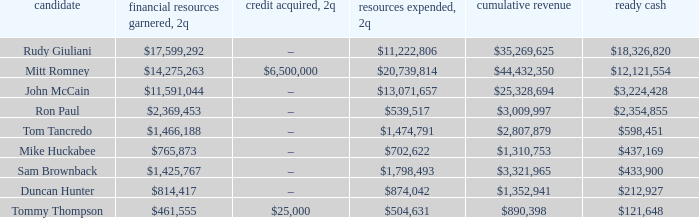Give me the full table as a dictionary. {'header': ['candidate', 'financial resources garnered, 2q', 'credit acquired, 2q', 'resources expended, 2q', 'cumulative revenue', 'ready cash'], 'rows': [['Rudy Giuliani', '$17,599,292', '–', '$11,222,806', '$35,269,625', '$18,326,820'], ['Mitt Romney', '$14,275,263', '$6,500,000', '$20,739,814', '$44,432,350', '$12,121,554'], ['John McCain', '$11,591,044', '–', '$13,071,657', '$25,328,694', '$3,224,428'], ['Ron Paul', '$2,369,453', '–', '$539,517', '$3,009,997', '$2,354,855'], ['Tom Tancredo', '$1,466,188', '–', '$1,474,791', '$2,807,879', '$598,451'], ['Mike Huckabee', '$765,873', '–', '$702,622', '$1,310,753', '$437,169'], ['Sam Brownback', '$1,425,767', '–', '$1,798,493', '$3,321,965', '$433,900'], ['Duncan Hunter', '$814,417', '–', '$874,042', '$1,352,941', '$212,927'], ['Tommy Thompson', '$461,555', '$25,000', '$504,631', '$890,398', '$121,648']]} Name the money raised when 2Q has money spent and 2Q is $874,042 $814,417. 